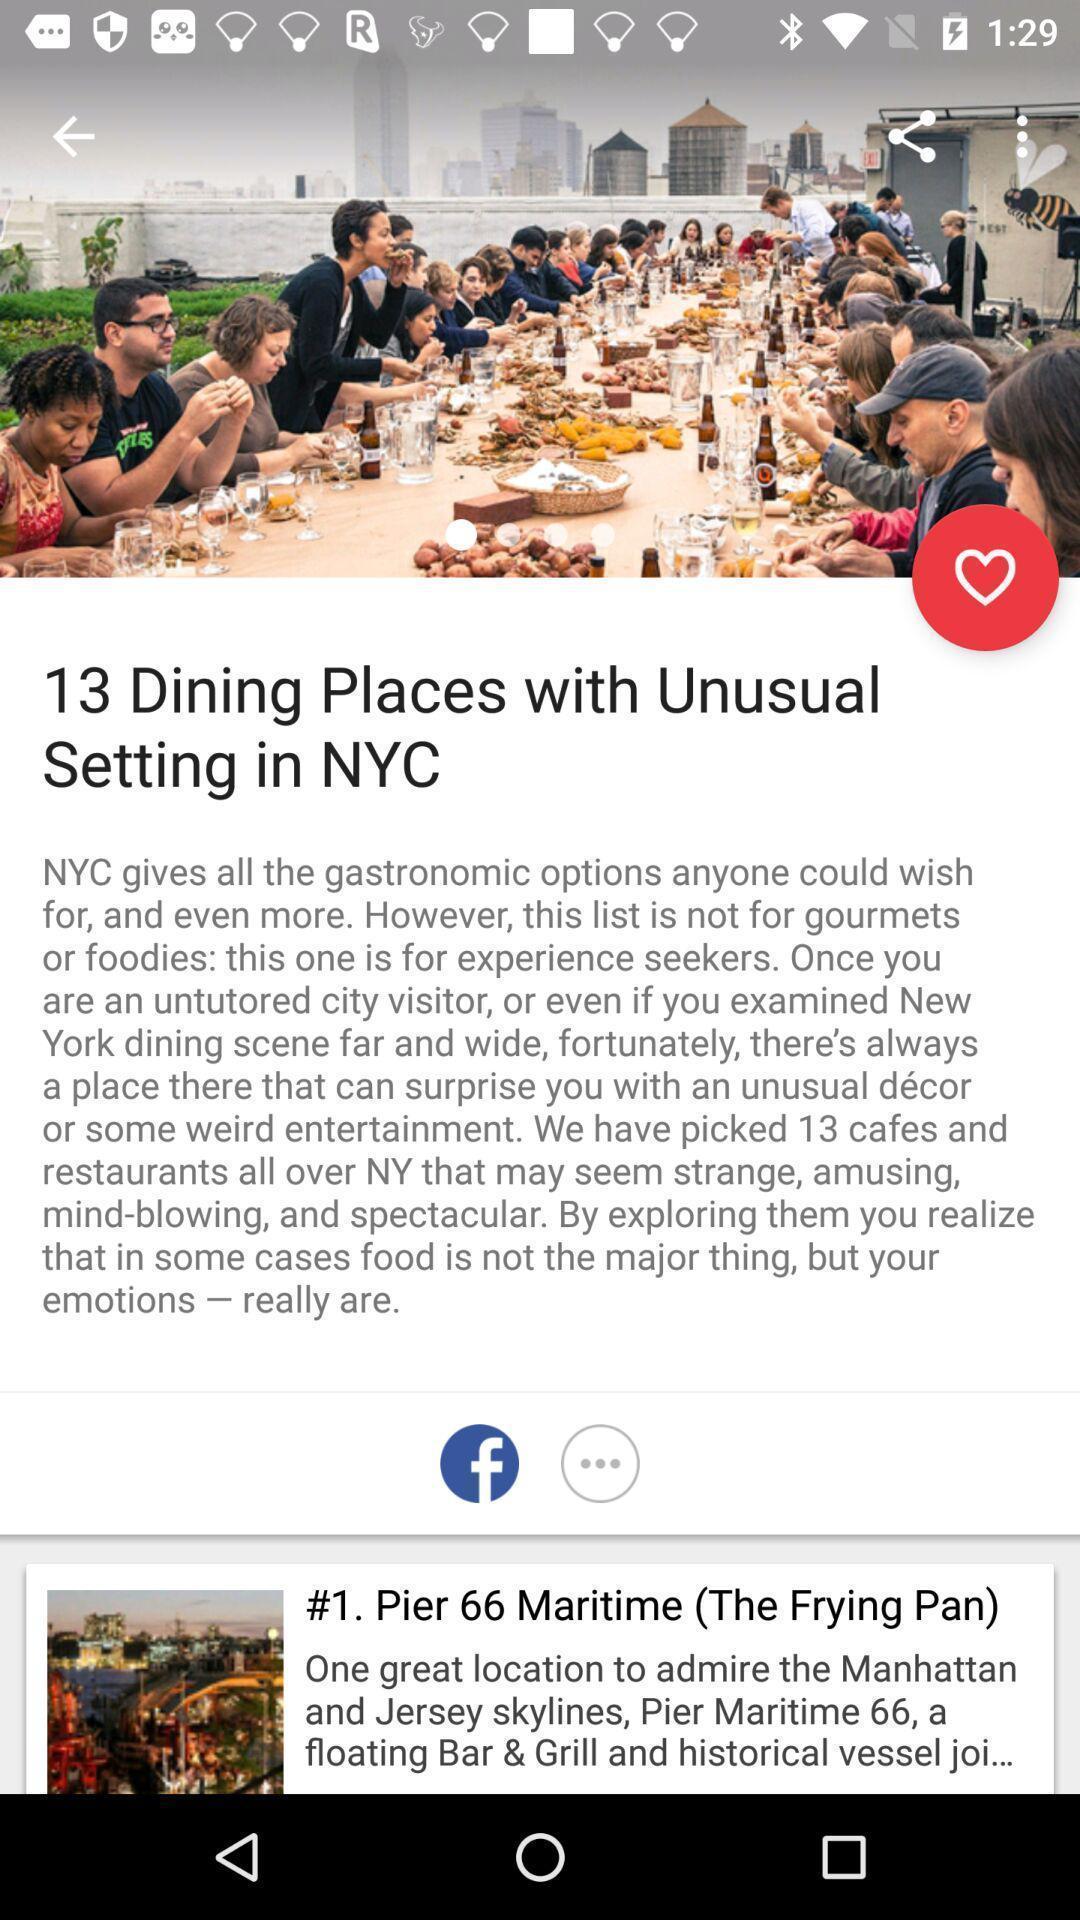Describe the key features of this screenshot. Page shows the notification of news on social app. 